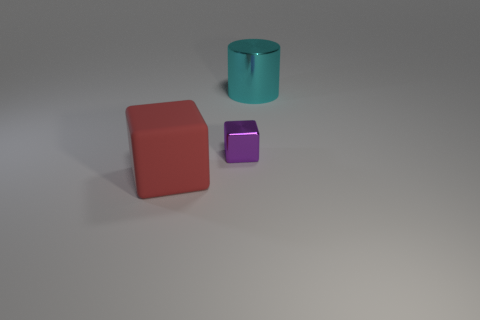Add 2 big cyan shiny objects. How many objects exist? 5 Subtract all cubes. How many objects are left? 1 Subtract 0 yellow cylinders. How many objects are left? 3 Subtract all large cyan cylinders. Subtract all large metallic things. How many objects are left? 1 Add 3 purple metal objects. How many purple metal objects are left? 4 Add 1 large purple cubes. How many large purple cubes exist? 1 